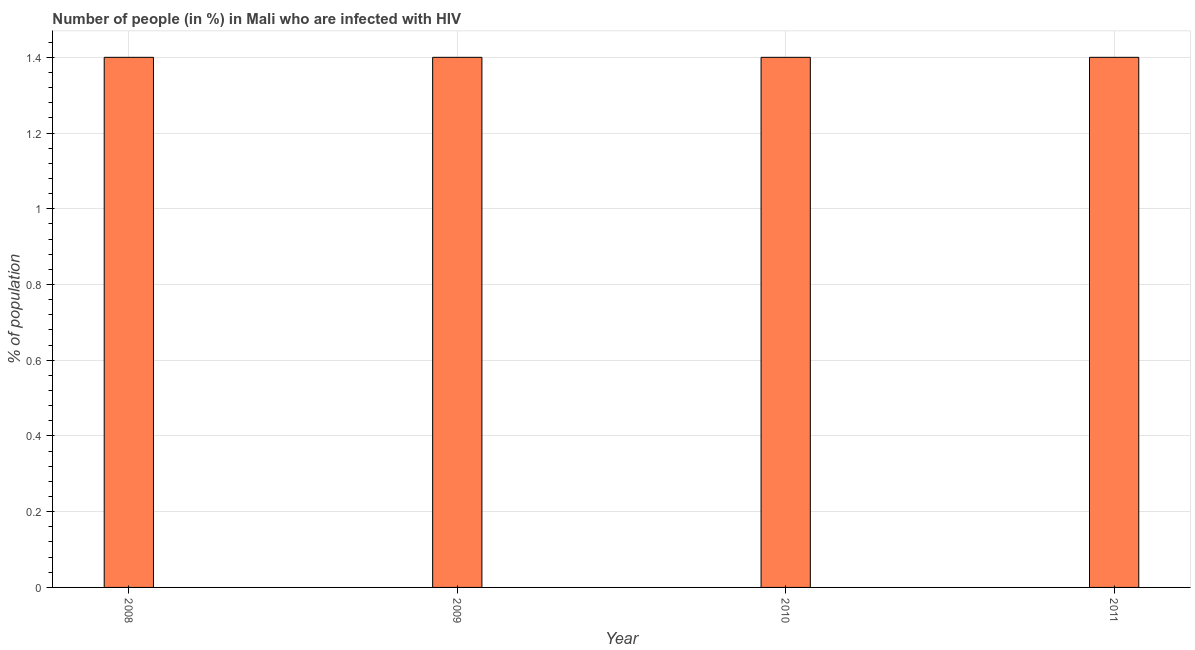Does the graph contain any zero values?
Your answer should be compact. No. Does the graph contain grids?
Your response must be concise. Yes. What is the title of the graph?
Offer a very short reply. Number of people (in %) in Mali who are infected with HIV. What is the label or title of the Y-axis?
Offer a terse response. % of population. In which year was the number of people infected with hiv maximum?
Your answer should be very brief. 2008. What is the sum of the number of people infected with hiv?
Offer a very short reply. 5.6. What is the ratio of the number of people infected with hiv in 2009 to that in 2011?
Ensure brevity in your answer.  1. What is the difference between the highest and the second highest number of people infected with hiv?
Offer a terse response. 0. Is the sum of the number of people infected with hiv in 2010 and 2011 greater than the maximum number of people infected with hiv across all years?
Offer a terse response. Yes. In how many years, is the number of people infected with hiv greater than the average number of people infected with hiv taken over all years?
Provide a succinct answer. 0. Are all the bars in the graph horizontal?
Offer a terse response. No. How many years are there in the graph?
Offer a terse response. 4. Are the values on the major ticks of Y-axis written in scientific E-notation?
Ensure brevity in your answer.  No. What is the % of population in 2008?
Offer a very short reply. 1.4. What is the % of population in 2009?
Provide a short and direct response. 1.4. What is the % of population in 2010?
Ensure brevity in your answer.  1.4. What is the difference between the % of population in 2008 and 2009?
Your response must be concise. 0. What is the difference between the % of population in 2008 and 2011?
Provide a short and direct response. 0. What is the difference between the % of population in 2009 and 2010?
Your response must be concise. 0. What is the difference between the % of population in 2010 and 2011?
Provide a succinct answer. 0. What is the ratio of the % of population in 2008 to that in 2009?
Your response must be concise. 1. What is the ratio of the % of population in 2009 to that in 2011?
Ensure brevity in your answer.  1. 